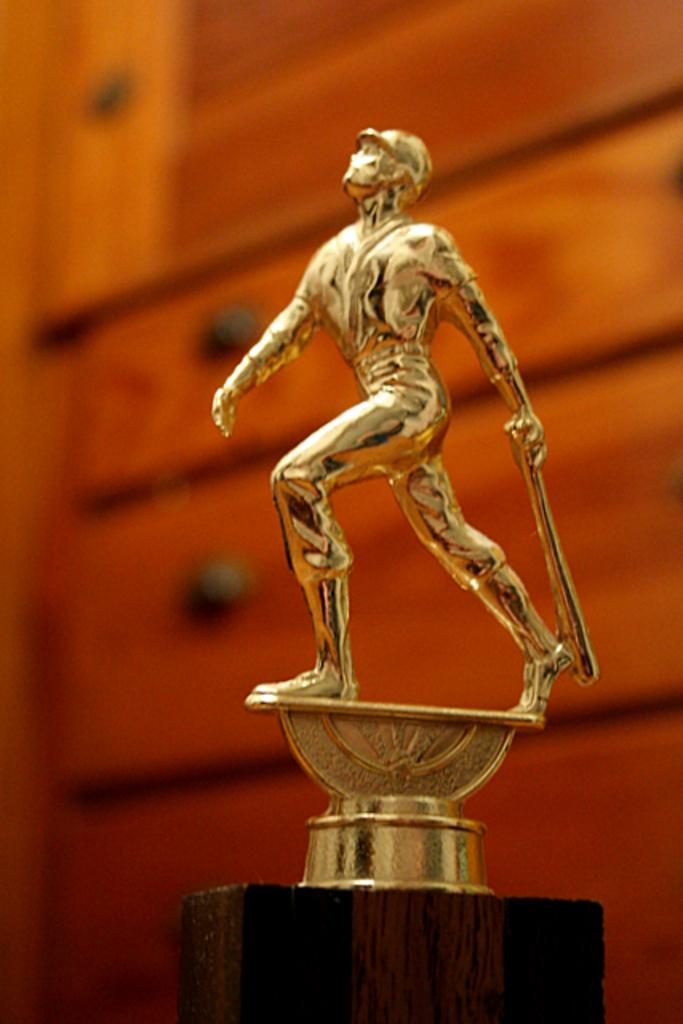What is the main subject in the image? There is a statue in the image. Can you describe the setting of the image? There is a wall in the background of the image. Where is the nearest hydrant to the statue in the image? There is no hydrant present in the image, so it cannot be determined from the image. 